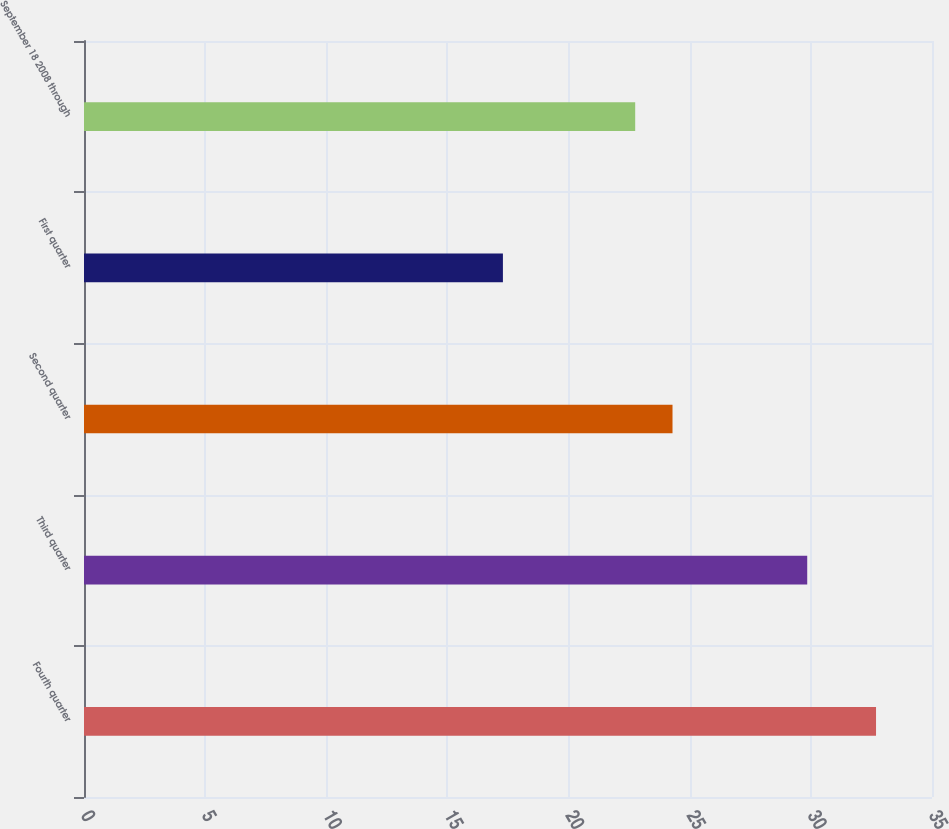Convert chart. <chart><loc_0><loc_0><loc_500><loc_500><bar_chart><fcel>Fourth quarter<fcel>Third quarter<fcel>Second quarter<fcel>First quarter<fcel>September 18 2008 through<nl><fcel>32.69<fcel>29.85<fcel>24.29<fcel>17.29<fcel>22.75<nl></chart> 